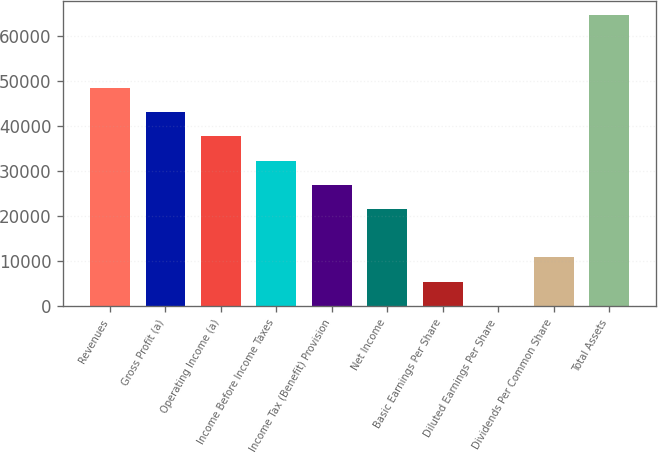Convert chart. <chart><loc_0><loc_0><loc_500><loc_500><bar_chart><fcel>Revenues<fcel>Gross Profit (a)<fcel>Operating Income (a)<fcel>Income Before Income Taxes<fcel>Income Tax (Benefit) Provision<fcel>Net Income<fcel>Basic Earnings Per Share<fcel>Diluted Earnings Per Share<fcel>Dividends Per Common Share<fcel>Total Assets<nl><fcel>48513.7<fcel>43123.3<fcel>37733<fcel>32342.6<fcel>26952.3<fcel>21562<fcel>5390.94<fcel>0.6<fcel>10781.3<fcel>64684.7<nl></chart> 